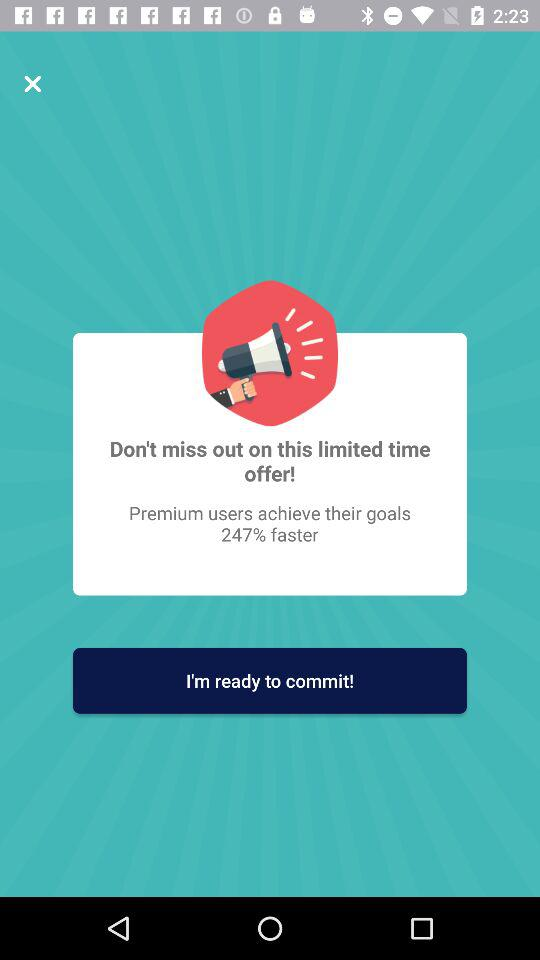How much faster do premium users achieve their goals than non-premium users?
Answer the question using a single word or phrase. 247% 